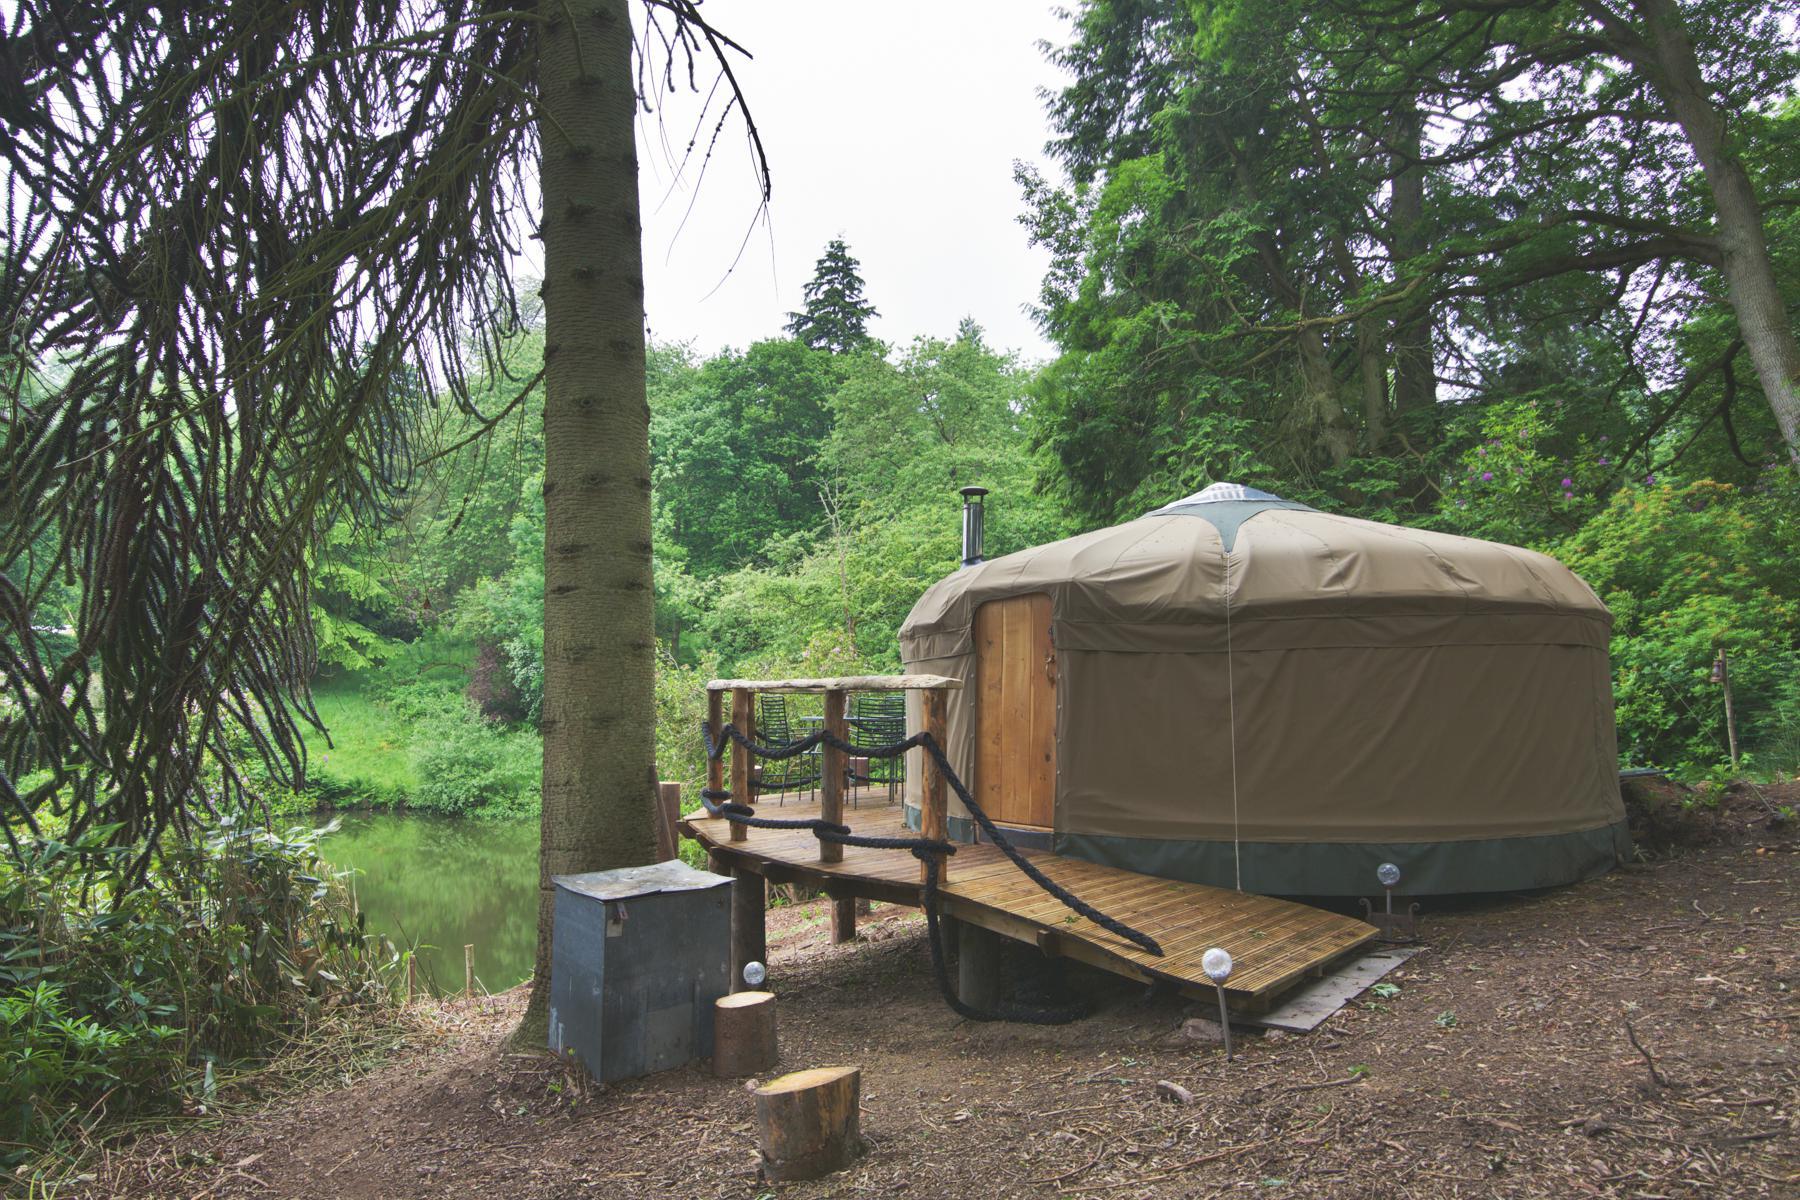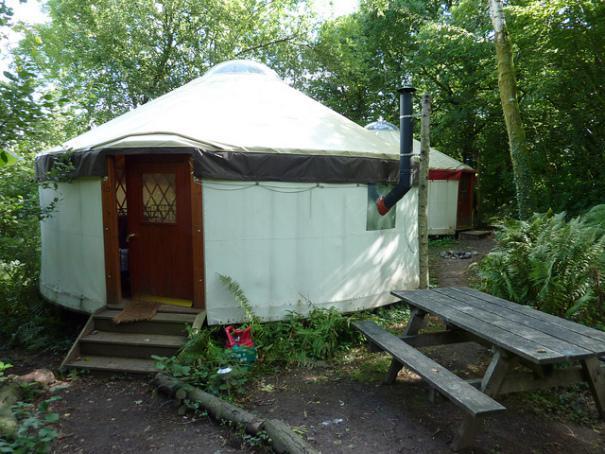The first image is the image on the left, the second image is the image on the right. Evaluate the accuracy of this statement regarding the images: "At least one yurt has a set of three or four wooden stairs that leads to the door.". Is it true? Answer yes or no. Yes. 